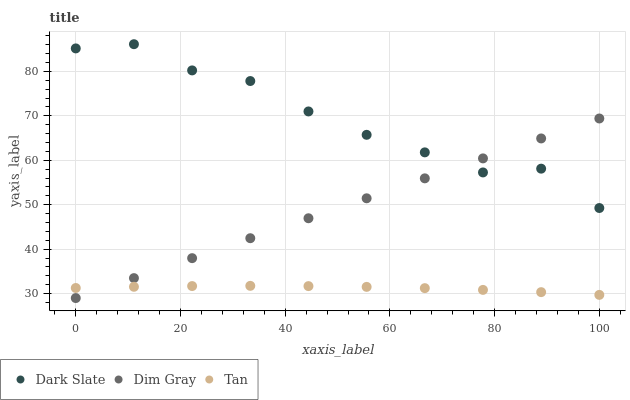Does Tan have the minimum area under the curve?
Answer yes or no. Yes. Does Dark Slate have the maximum area under the curve?
Answer yes or no. Yes. Does Dim Gray have the minimum area under the curve?
Answer yes or no. No. Does Dim Gray have the maximum area under the curve?
Answer yes or no. No. Is Dim Gray the smoothest?
Answer yes or no. Yes. Is Dark Slate the roughest?
Answer yes or no. Yes. Is Tan the smoothest?
Answer yes or no. No. Is Tan the roughest?
Answer yes or no. No. Does Dim Gray have the lowest value?
Answer yes or no. Yes. Does Tan have the lowest value?
Answer yes or no. No. Does Dark Slate have the highest value?
Answer yes or no. Yes. Does Dim Gray have the highest value?
Answer yes or no. No. Is Tan less than Dark Slate?
Answer yes or no. Yes. Is Dark Slate greater than Tan?
Answer yes or no. Yes. Does Dim Gray intersect Dark Slate?
Answer yes or no. Yes. Is Dim Gray less than Dark Slate?
Answer yes or no. No. Is Dim Gray greater than Dark Slate?
Answer yes or no. No. Does Tan intersect Dark Slate?
Answer yes or no. No. 